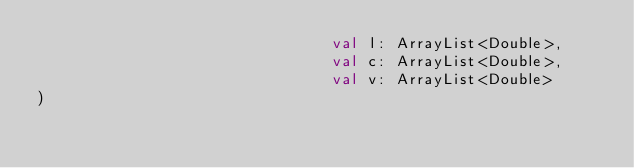<code> <loc_0><loc_0><loc_500><loc_500><_Kotlin_>                                val l: ArrayList<Double>,
                                val c: ArrayList<Double>,
                                val v: ArrayList<Double>
)</code> 